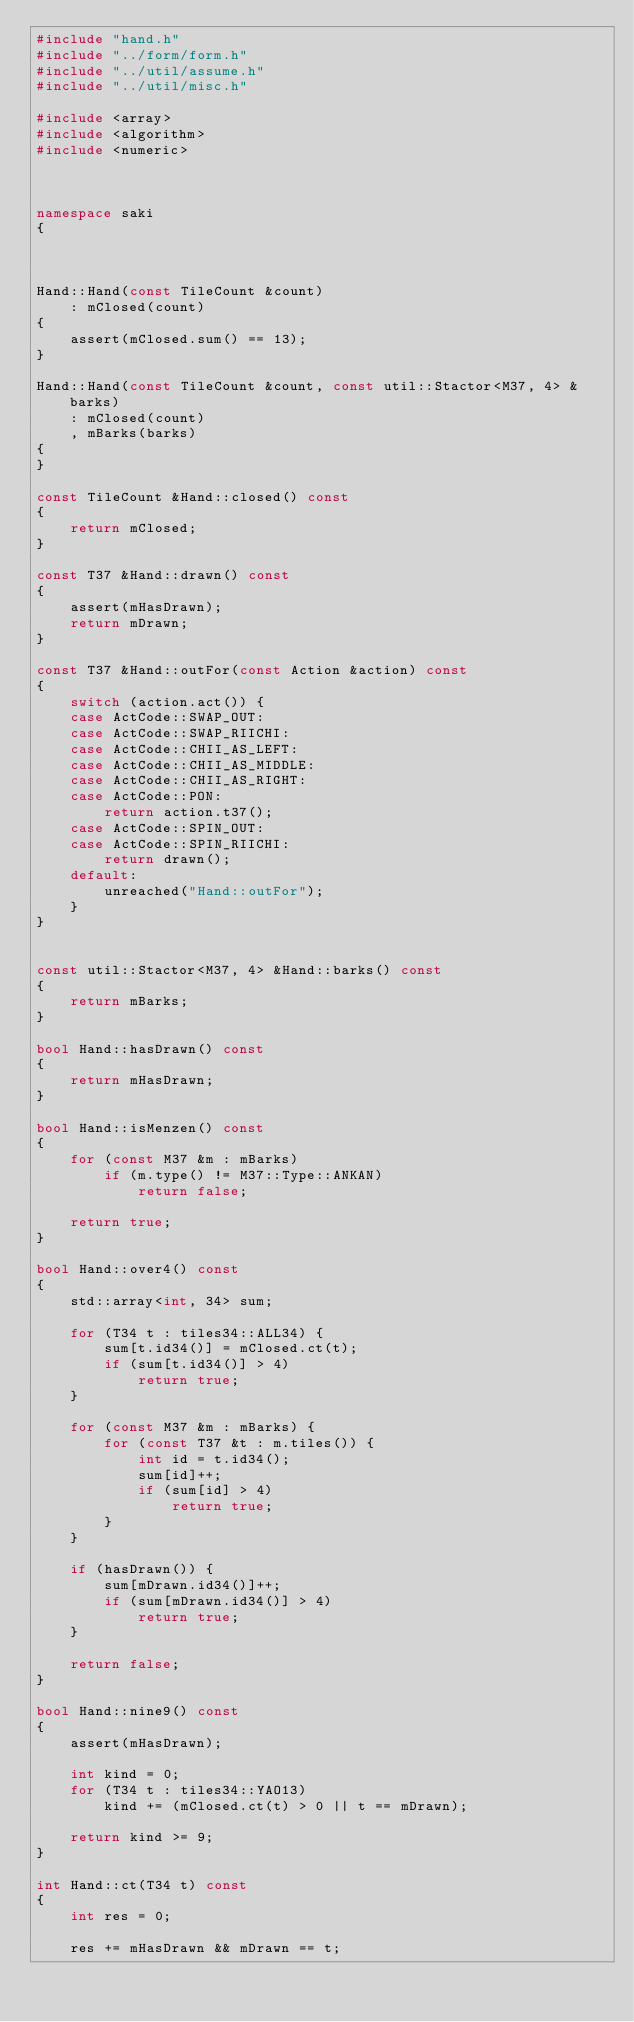Convert code to text. <code><loc_0><loc_0><loc_500><loc_500><_C++_>#include "hand.h"
#include "../form/form.h"
#include "../util/assume.h"
#include "../util/misc.h"

#include <array>
#include <algorithm>
#include <numeric>



namespace saki
{



Hand::Hand(const TileCount &count)
    : mClosed(count)
{
    assert(mClosed.sum() == 13);
}

Hand::Hand(const TileCount &count, const util::Stactor<M37, 4> &barks)
    : mClosed(count)
    , mBarks(barks)
{
}

const TileCount &Hand::closed() const
{
    return mClosed;
}

const T37 &Hand::drawn() const
{
    assert(mHasDrawn);
    return mDrawn;
}

const T37 &Hand::outFor(const Action &action) const
{
    switch (action.act()) {
    case ActCode::SWAP_OUT:
    case ActCode::SWAP_RIICHI:
    case ActCode::CHII_AS_LEFT:
    case ActCode::CHII_AS_MIDDLE:
    case ActCode::CHII_AS_RIGHT:
    case ActCode::PON:
        return action.t37();
    case ActCode::SPIN_OUT:
    case ActCode::SPIN_RIICHI:
        return drawn();
    default:
        unreached("Hand::outFor");
    }
}


const util::Stactor<M37, 4> &Hand::barks() const
{
    return mBarks;
}

bool Hand::hasDrawn() const
{
    return mHasDrawn;
}

bool Hand::isMenzen() const
{
    for (const M37 &m : mBarks)
        if (m.type() != M37::Type::ANKAN)
            return false;

    return true;
}

bool Hand::over4() const
{
    std::array<int, 34> sum;

    for (T34 t : tiles34::ALL34) {
        sum[t.id34()] = mClosed.ct(t);
        if (sum[t.id34()] > 4)
            return true;
    }

    for (const M37 &m : mBarks) {
        for (const T37 &t : m.tiles()) {
            int id = t.id34();
            sum[id]++;
            if (sum[id] > 4)
                return true;
        }
    }

    if (hasDrawn()) {
        sum[mDrawn.id34()]++;
        if (sum[mDrawn.id34()] > 4)
            return true;
    }

    return false;
}

bool Hand::nine9() const
{
    assert(mHasDrawn);

    int kind = 0;
    for (T34 t : tiles34::YAO13)
        kind += (mClosed.ct(t) > 0 || t == mDrawn);

    return kind >= 9;
}

int Hand::ct(T34 t) const
{
    int res = 0;

    res += mHasDrawn && mDrawn == t;</code> 